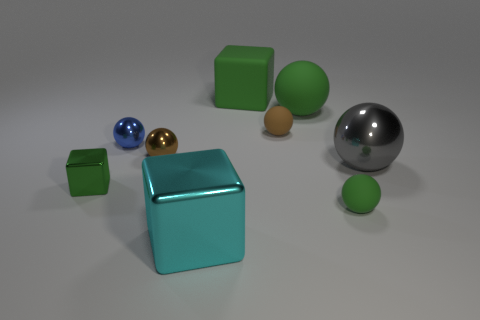What is the size of the cube behind the tiny blue metal sphere?
Keep it short and to the point. Large. What number of green things are large balls or large blocks?
Provide a succinct answer. 2. What material is the cyan thing that is the same shape as the tiny green metallic thing?
Ensure brevity in your answer.  Metal. Is the number of large matte blocks that are to the left of the tiny brown shiny thing the same as the number of red spheres?
Make the answer very short. Yes. There is a metal thing that is both behind the large cyan metallic object and to the right of the tiny brown metallic ball; what size is it?
Make the answer very short. Large. Is there anything else of the same color as the large metallic cube?
Keep it short and to the point. No. What size is the metallic ball that is behind the tiny brown object left of the big green cube?
Your response must be concise. Small. What color is the block that is both right of the tiny green block and behind the cyan block?
Your response must be concise. Green. What number of other objects are the same size as the brown rubber thing?
Provide a succinct answer. 4. There is a blue thing; is it the same size as the green sphere that is behind the gray metal ball?
Your answer should be compact. No. 